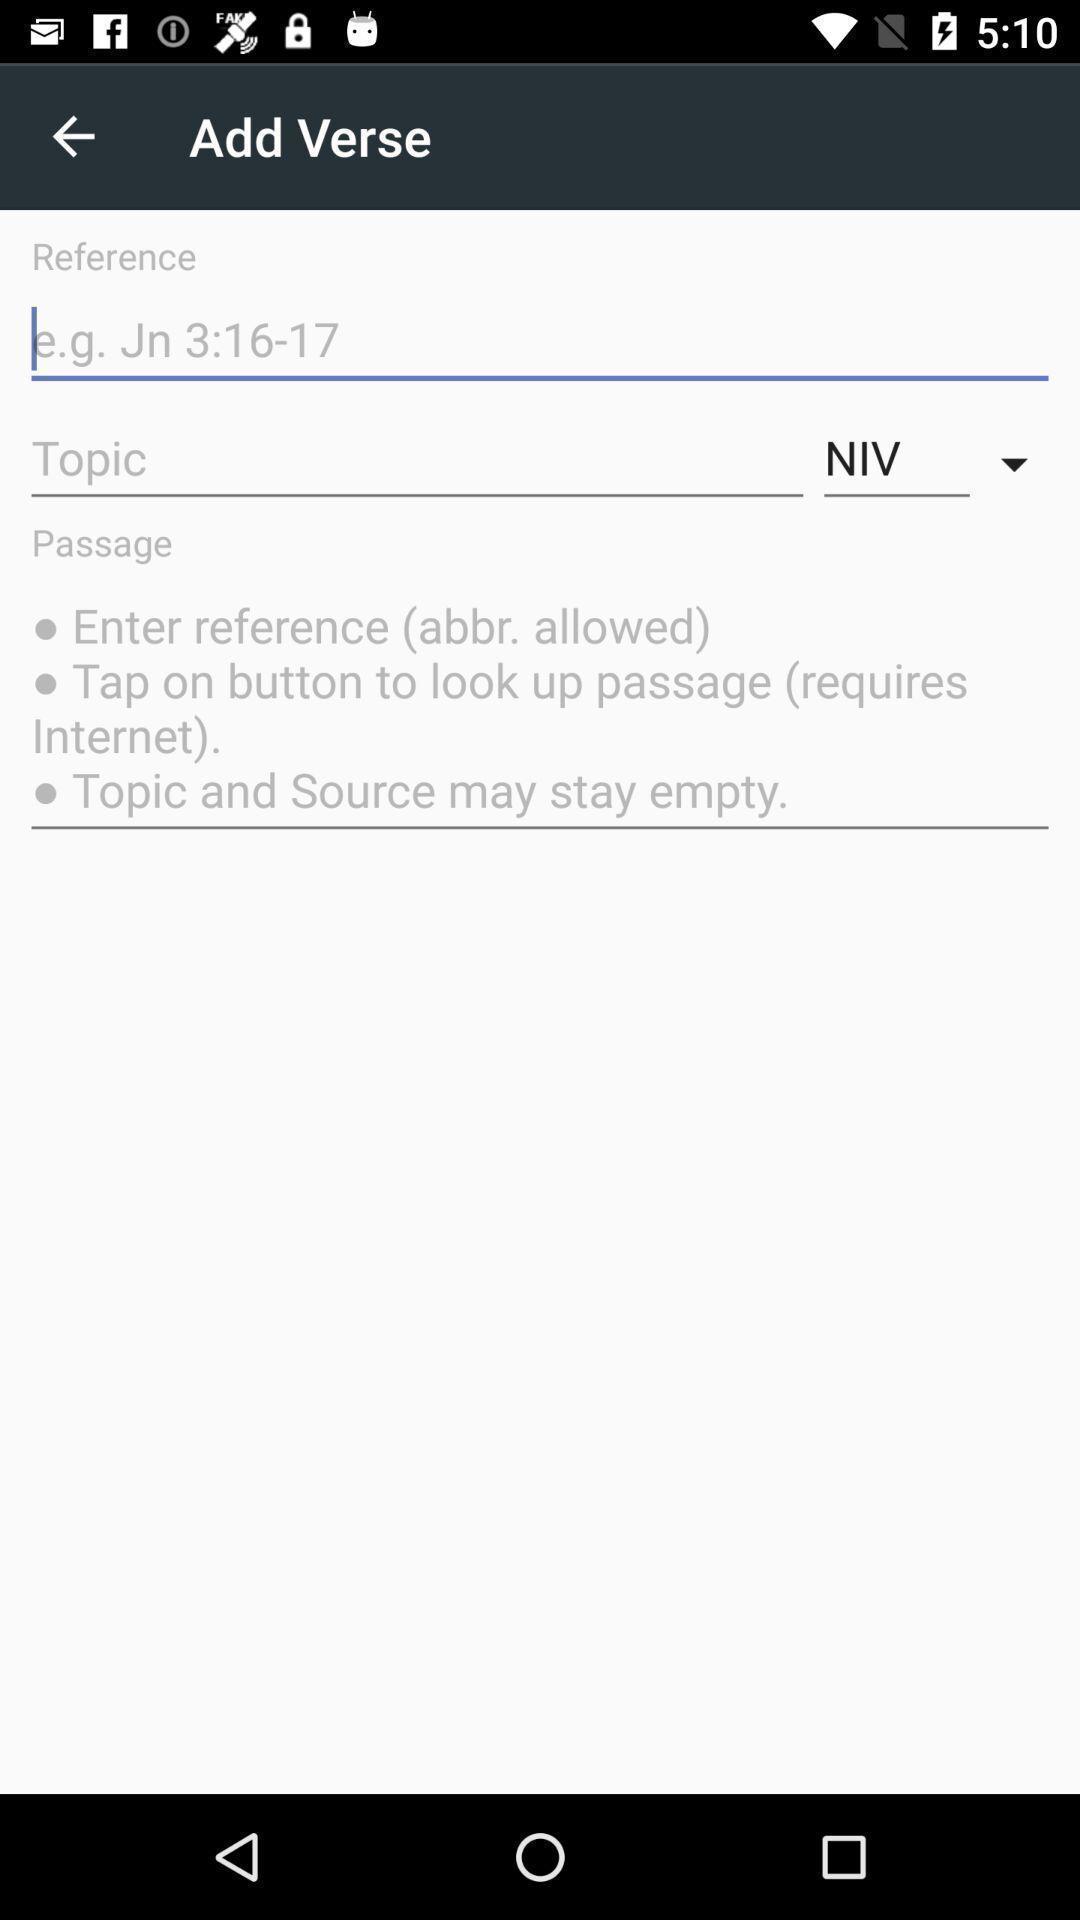Provide a detailed account of this screenshot. Page showing information about bible. 